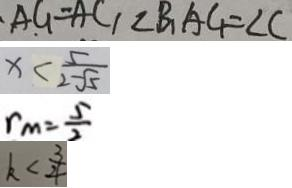<formula> <loc_0><loc_0><loc_500><loc_500>A G = A C 1 \angle B _ { 1 } A C _ { 1 } = \angle C 
 x < \frac { 5 } { 2 - \sqrt { 5 } } 
 r _ { m } = \frac { 5 } { 2 } 
 k < \frac { 3 } { 4 }</formula> 